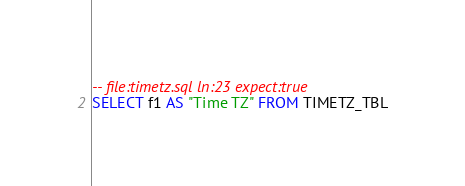Convert code to text. <code><loc_0><loc_0><loc_500><loc_500><_SQL_>-- file:timetz.sql ln:23 expect:true
SELECT f1 AS "Time TZ" FROM TIMETZ_TBL
</code> 